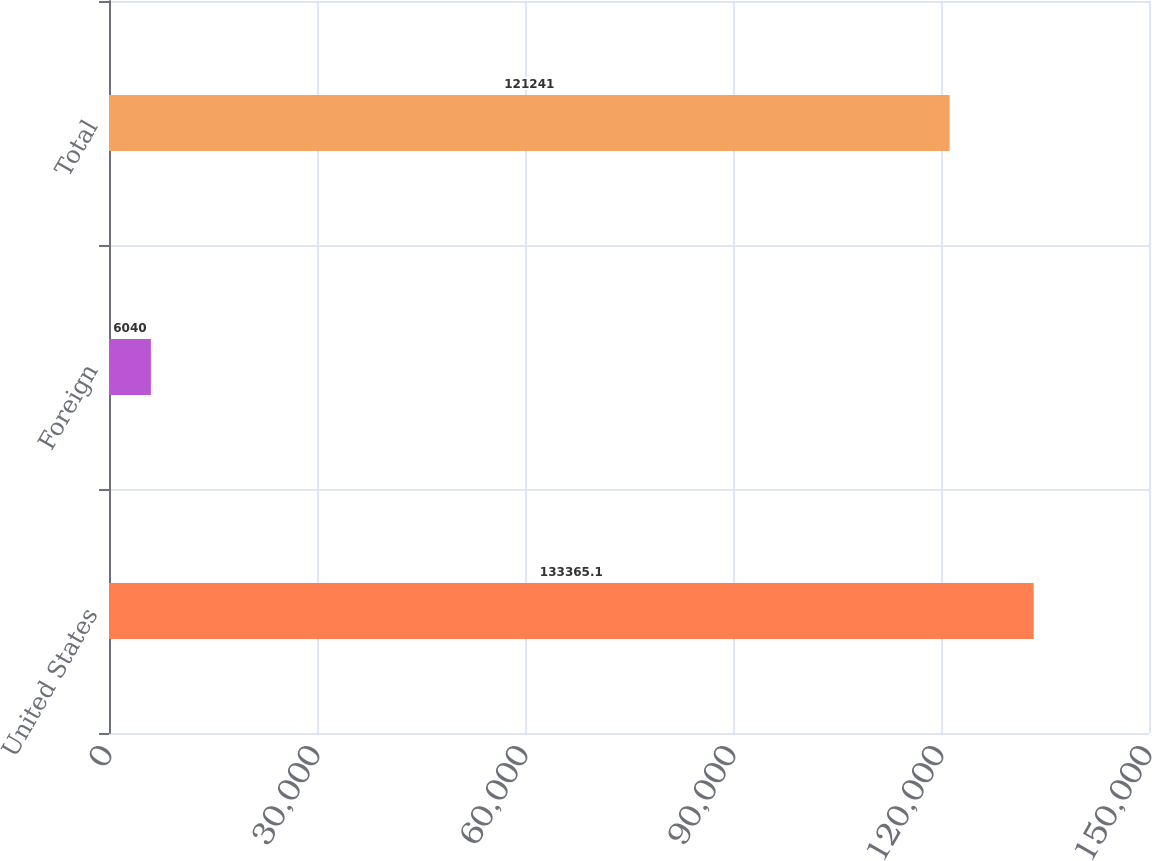Convert chart. <chart><loc_0><loc_0><loc_500><loc_500><bar_chart><fcel>United States<fcel>Foreign<fcel>Total<nl><fcel>133365<fcel>6040<fcel>121241<nl></chart> 